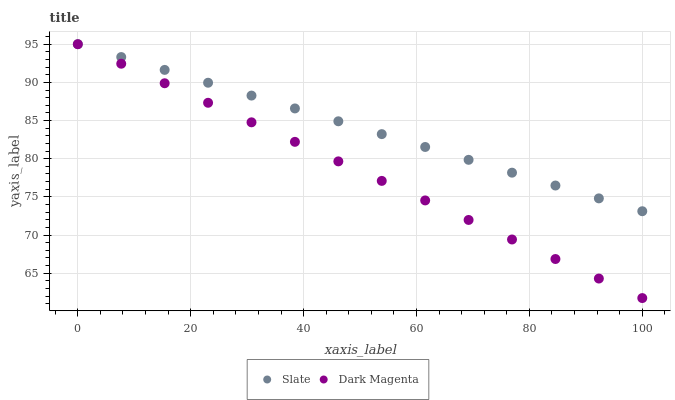Does Dark Magenta have the minimum area under the curve?
Answer yes or no. Yes. Does Slate have the maximum area under the curve?
Answer yes or no. Yes. Does Dark Magenta have the maximum area under the curve?
Answer yes or no. No. Is Dark Magenta the smoothest?
Answer yes or no. Yes. Is Slate the roughest?
Answer yes or no. Yes. Is Dark Magenta the roughest?
Answer yes or no. No. Does Dark Magenta have the lowest value?
Answer yes or no. Yes. Does Dark Magenta have the highest value?
Answer yes or no. Yes. Does Dark Magenta intersect Slate?
Answer yes or no. Yes. Is Dark Magenta less than Slate?
Answer yes or no. No. Is Dark Magenta greater than Slate?
Answer yes or no. No. 